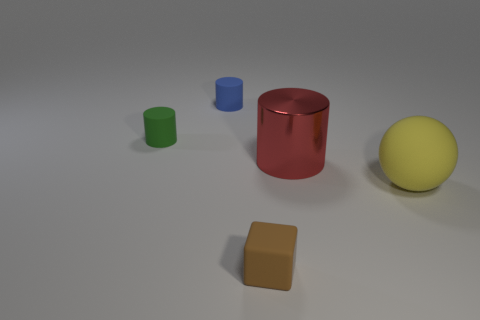Is there any other thing that is the same material as the big red cylinder?
Give a very brief answer. No. What shape is the brown object that is the same size as the blue matte thing?
Provide a short and direct response. Cube. There is a object that is in front of the matte thing to the right of the red metal cylinder; what is it made of?
Make the answer very short. Rubber. Does the green cylinder have the same size as the rubber ball?
Offer a very short reply. No. What number of objects are rubber objects that are behind the yellow thing or small rubber things?
Provide a short and direct response. 3. There is a matte object to the right of the tiny matte thing that is in front of the big sphere; what shape is it?
Keep it short and to the point. Sphere. Do the blue rubber cylinder and the cylinder that is to the right of the blue rubber thing have the same size?
Offer a terse response. No. There is a cylinder on the right side of the small blue rubber object; what is it made of?
Provide a succinct answer. Metal. What number of rubber things are in front of the big red object and left of the large yellow ball?
Your response must be concise. 1. What is the material of the other cylinder that is the same size as the green cylinder?
Provide a succinct answer. Rubber. 